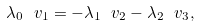Convert formula to latex. <formula><loc_0><loc_0><loc_500><loc_500>\lambda _ { 0 } \ v _ { 1 } = - \lambda _ { 1 } \ v _ { 2 } - \lambda _ { 2 } \ v _ { 3 } ,</formula> 